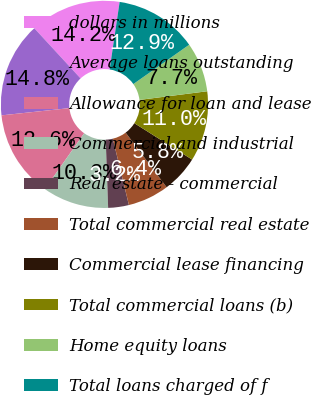Convert chart. <chart><loc_0><loc_0><loc_500><loc_500><pie_chart><fcel>dollars in millions<fcel>Average loans outstanding<fcel>Allowance for loan and lease<fcel>Commercial and industrial<fcel>Real estate - commercial<fcel>Total commercial real estate<fcel>Commercial lease financing<fcel>Total commercial loans (b)<fcel>Home equity loans<fcel>Total loans charged of f<nl><fcel>14.19%<fcel>14.84%<fcel>13.55%<fcel>10.32%<fcel>3.23%<fcel>6.45%<fcel>5.81%<fcel>10.97%<fcel>7.74%<fcel>12.9%<nl></chart> 